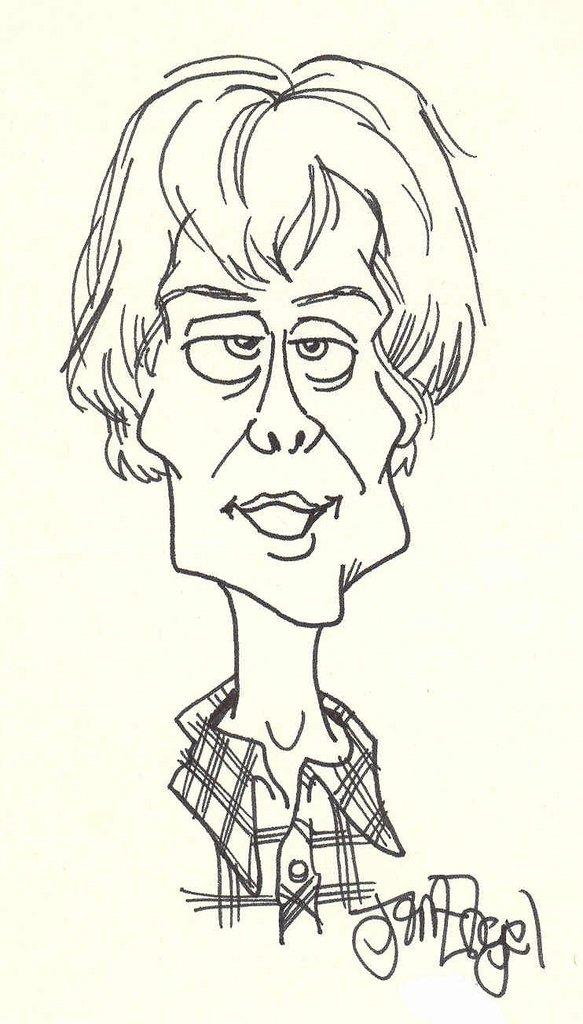What type of drawing is present in the image? The image contains a sketch of a cartoon. What color scheme is used for the sketch? The sketch is in black and white. Is there any additional information or markings in the image? Yes, there is a watermark in the right bottom corner of the image. What degree of disgust is expressed by the cartoon character in the image? There is no indication of the cartoon character's emotions or expressions in the image, so it cannot be determined if they are expressing disgust. What type of writing instrument is used by the cartoon character in the image? The image is a sketch, not a drawing with a character holding a writing instrument. Therefore, it cannot be determined what type of writing instrument the cartoon character might be using. 